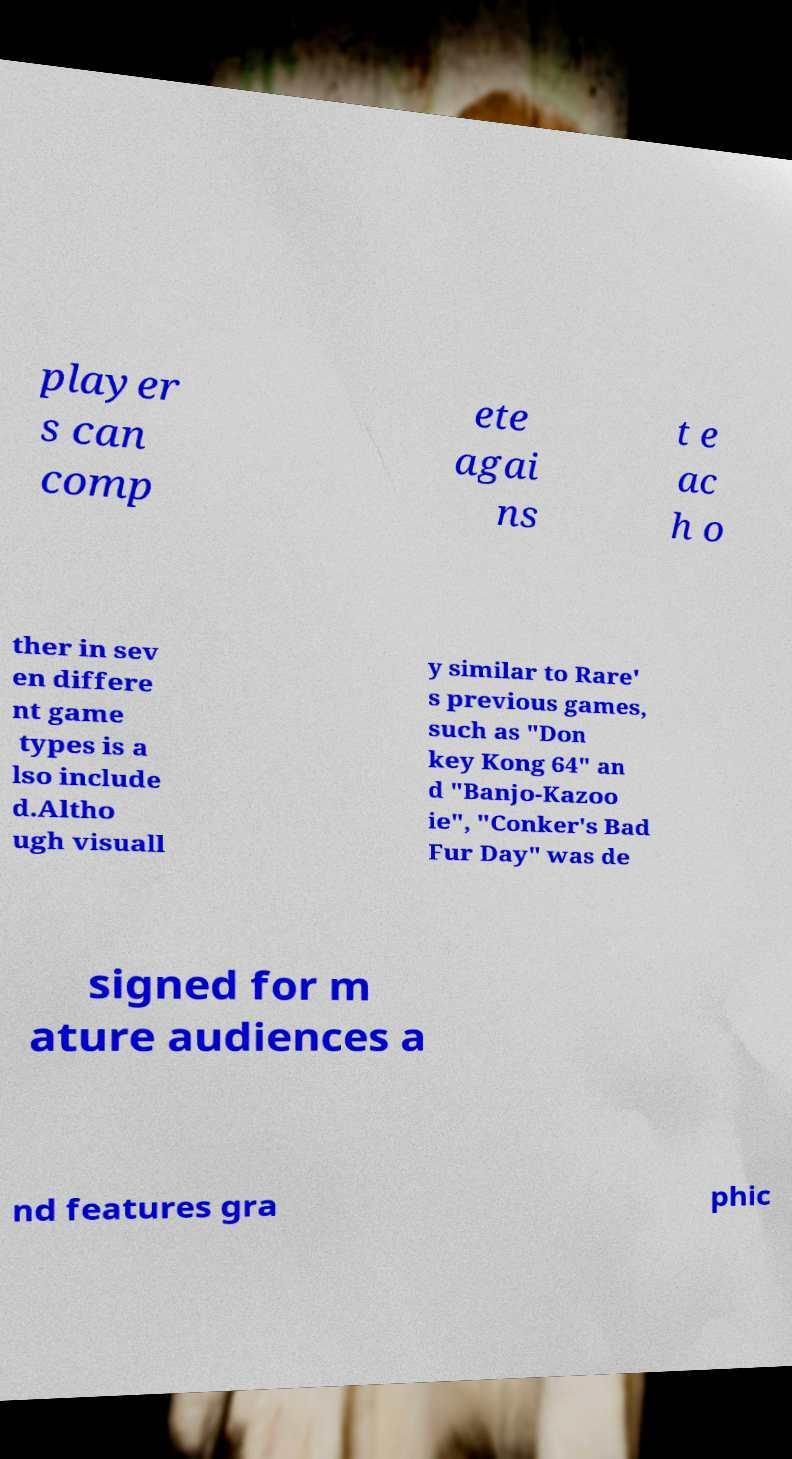Can you accurately transcribe the text from the provided image for me? player s can comp ete agai ns t e ac h o ther in sev en differe nt game types is a lso include d.Altho ugh visuall y similar to Rare' s previous games, such as "Don key Kong 64" an d "Banjo-Kazoo ie", "Conker's Bad Fur Day" was de signed for m ature audiences a nd features gra phic 